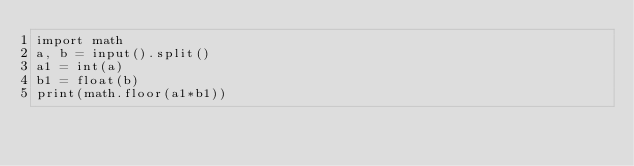<code> <loc_0><loc_0><loc_500><loc_500><_Python_>import math
a, b = input().split()
a1 = int(a)
b1 = float(b)
print(math.floor(a1*b1))</code> 